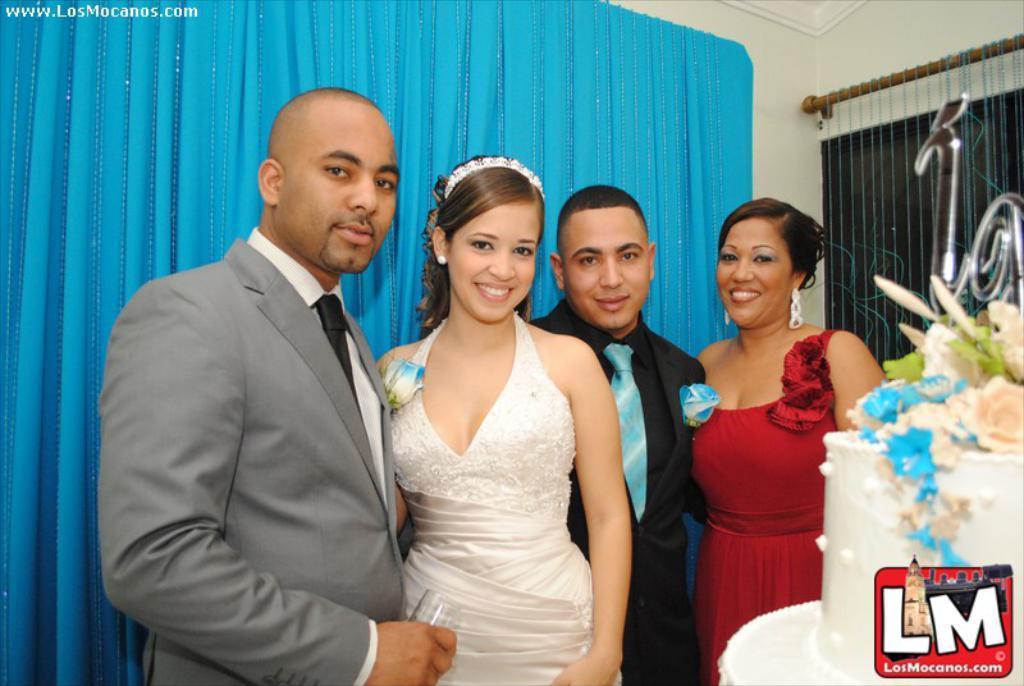How would you summarize this image in a sentence or two? This picture is clicked inside the room. Here, we see four people standing. Among them, two are men and two are women and all of them are smiling. Behind them, we see a blue curtain and a white wall. In the right bottom of the picture, we see a cake placed on the table and we even see the logo of the company. 